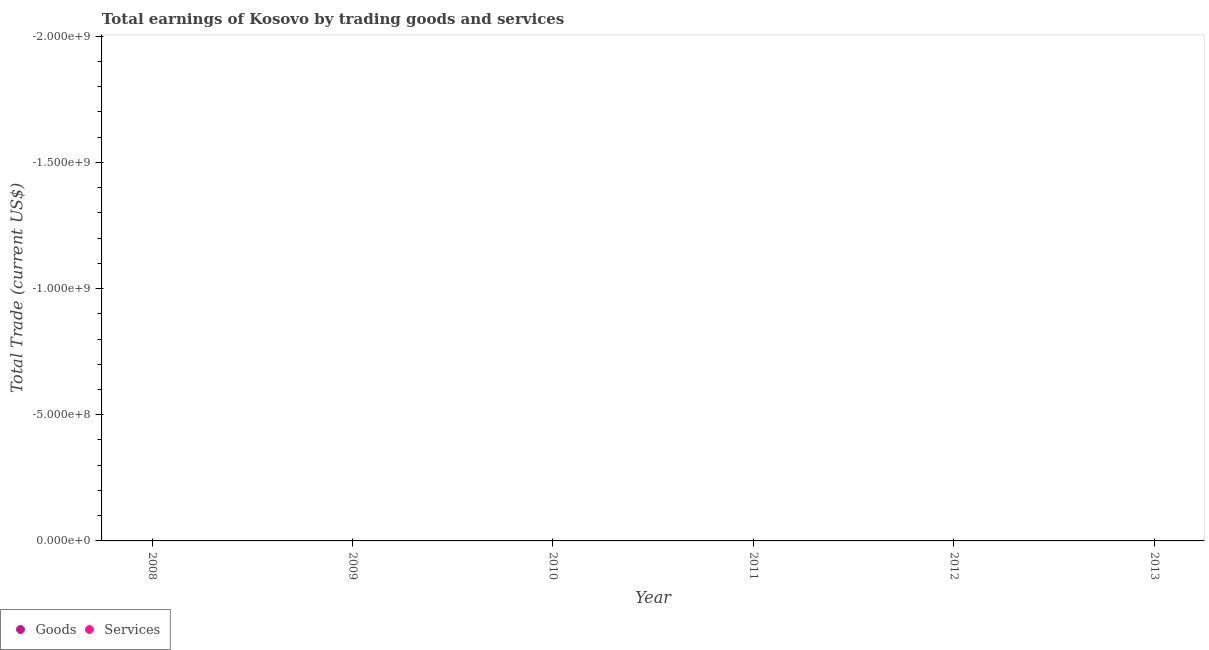How many different coloured dotlines are there?
Offer a very short reply. 0. Is the number of dotlines equal to the number of legend labels?
Your response must be concise. No. Across all years, what is the minimum amount earned by trading goods?
Provide a succinct answer. 0. What is the average amount earned by trading goods per year?
Provide a succinct answer. 0. Is the amount earned by trading services strictly greater than the amount earned by trading goods over the years?
Provide a succinct answer. Yes. Is the amount earned by trading services strictly less than the amount earned by trading goods over the years?
Make the answer very short. No. How many dotlines are there?
Your answer should be very brief. 0. How many years are there in the graph?
Your response must be concise. 6. Are the values on the major ticks of Y-axis written in scientific E-notation?
Offer a very short reply. Yes. Does the graph contain grids?
Your response must be concise. No. How many legend labels are there?
Provide a short and direct response. 2. How are the legend labels stacked?
Ensure brevity in your answer.  Horizontal. What is the title of the graph?
Ensure brevity in your answer.  Total earnings of Kosovo by trading goods and services. What is the label or title of the X-axis?
Make the answer very short. Year. What is the label or title of the Y-axis?
Your response must be concise. Total Trade (current US$). What is the Total Trade (current US$) of Goods in 2008?
Your response must be concise. 0. What is the Total Trade (current US$) of Services in 2009?
Provide a short and direct response. 0. What is the Total Trade (current US$) in Goods in 2010?
Make the answer very short. 0. What is the Total Trade (current US$) in Services in 2011?
Your answer should be very brief. 0. What is the Total Trade (current US$) of Goods in 2013?
Give a very brief answer. 0. What is the Total Trade (current US$) in Services in 2013?
Give a very brief answer. 0. What is the total Total Trade (current US$) of Services in the graph?
Keep it short and to the point. 0. What is the average Total Trade (current US$) of Goods per year?
Your response must be concise. 0. 